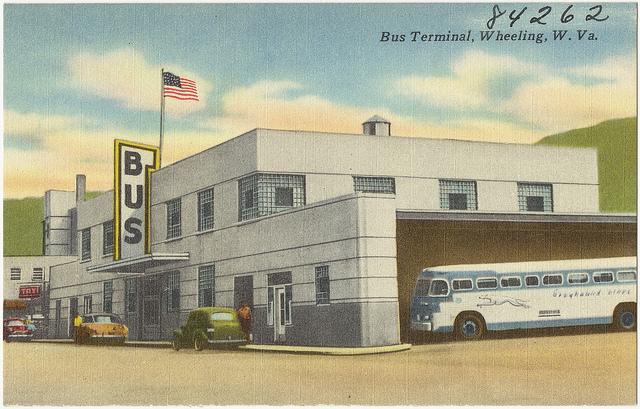Where is the truck parked?
Write a very short answer. Beside building. What year is on the picture?
Answer briefly. 0. Where is this bus terminal?
Give a very brief answer. Wheeling, wv. Where is this?
Quick response, please. Bus terminal. What colors are in the flag?
Give a very brief answer. Red white blue. What is the name of the venue?
Keep it brief. Bus terminal. What type of bus is on the right?
Be succinct. Greyhound. What is the symbol on the flag?
Keep it brief. Stars and stripes. How can you tell there taxis in this photo?
Short answer required. Color of car. Is the road paved?
Answer briefly. No. What does it say after street scene?
Give a very brief answer. Bus. What is in the middle of the photo?
Concise answer only. Building. Do you see a security camera?
Concise answer only. No. 